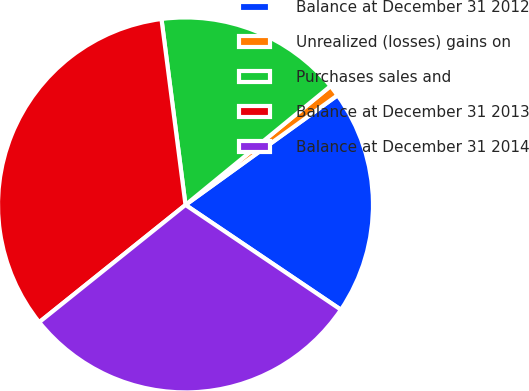<chart> <loc_0><loc_0><loc_500><loc_500><pie_chart><fcel>Balance at December 31 2012<fcel>Unrealized (losses) gains on<fcel>Purchases sales and<fcel>Balance at December 31 2013<fcel>Balance at December 31 2014<nl><fcel>19.39%<fcel>0.98%<fcel>16.12%<fcel>33.71%<fcel>29.8%<nl></chart> 